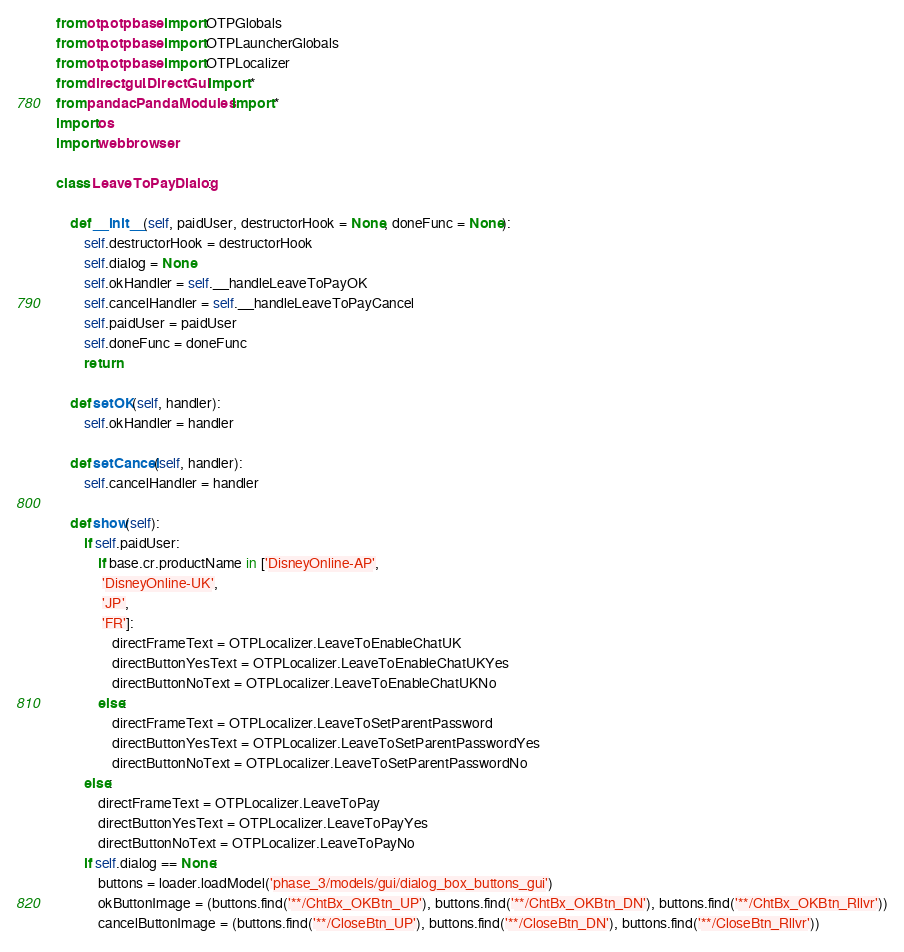<code> <loc_0><loc_0><loc_500><loc_500><_Python_>from otp.otpbase import OTPGlobals
from otp.otpbase import OTPLauncherGlobals
from otp.otpbase import OTPLocalizer
from direct.gui.DirectGui import *
from pandac.PandaModules import *
import os
import webbrowser

class LeaveToPayDialog:

    def __init__(self, paidUser, destructorHook = None, doneFunc = None):
        self.destructorHook = destructorHook
        self.dialog = None
        self.okHandler = self.__handleLeaveToPayOK
        self.cancelHandler = self.__handleLeaveToPayCancel
        self.paidUser = paidUser
        self.doneFunc = doneFunc
        return

    def setOK(self, handler):
        self.okHandler = handler

    def setCancel(self, handler):
        self.cancelHandler = handler

    def show(self):
        if self.paidUser:
            if base.cr.productName in ['DisneyOnline-AP',
             'DisneyOnline-UK',
             'JP',
             'FR']:
                directFrameText = OTPLocalizer.LeaveToEnableChatUK
                directButtonYesText = OTPLocalizer.LeaveToEnableChatUKYes
                directButtonNoText = OTPLocalizer.LeaveToEnableChatUKNo
            else:
                directFrameText = OTPLocalizer.LeaveToSetParentPassword
                directButtonYesText = OTPLocalizer.LeaveToSetParentPasswordYes
                directButtonNoText = OTPLocalizer.LeaveToSetParentPasswordNo
        else:
            directFrameText = OTPLocalizer.LeaveToPay
            directButtonYesText = OTPLocalizer.LeaveToPayYes
            directButtonNoText = OTPLocalizer.LeaveToPayNo
        if self.dialog == None:
            buttons = loader.loadModel('phase_3/models/gui/dialog_box_buttons_gui')
            okButtonImage = (buttons.find('**/ChtBx_OKBtn_UP'), buttons.find('**/ChtBx_OKBtn_DN'), buttons.find('**/ChtBx_OKBtn_Rllvr'))
            cancelButtonImage = (buttons.find('**/CloseBtn_UP'), buttons.find('**/CloseBtn_DN'), buttons.find('**/CloseBtn_Rllvr'))</code> 